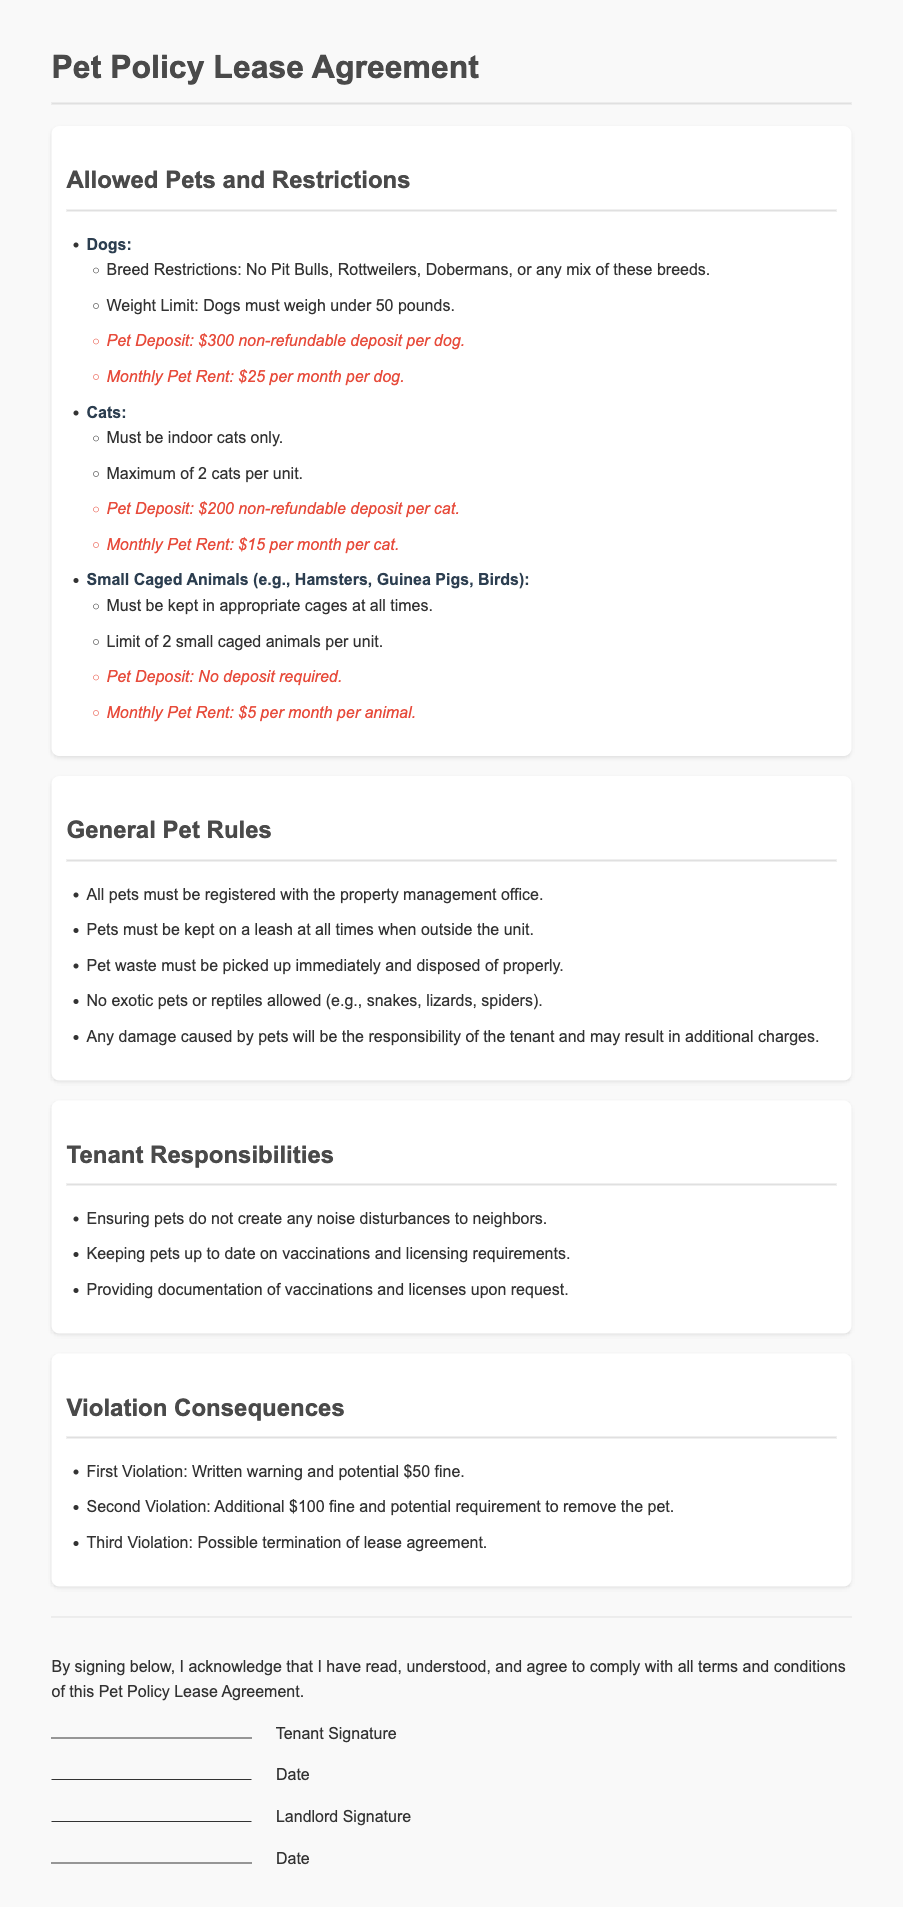What are the breed restrictions for dogs? The breed restrictions for dogs include No Pit Bulls, Rottweilers, Dobermans, or any mix of these breeds.
Answer: No Pit Bulls, Rottweilers, Dobermans What is the pet deposit for cats? The pet deposit for cats is mentioned in the document, which is $200 non-refundable deposit per cat.
Answer: $200 How many small caged animals are allowed per unit? The document specifies the limit for small caged animals, which is a maximum of 2 small caged animals per unit.
Answer: 2 What is the monthly pet rent for dogs? The document states that the monthly pet rent for dogs is $25 per month per dog.
Answer: $25 What consequence follows a second violation? The consequence for a second violation includes an additional fine and the potential requirement to remove the pet.
Answer: Additional $100 fine and potential removal How must pets be managed while outside the unit? The document outlines that pets must be kept on a leash at all times when outside the unit.
Answer: On a leash What documentation must tenants provide upon request? The tenants are required to provide documentation of vaccinations and licenses upon request.
Answer: Vaccinations and licenses What type of pets are explicitly not allowed? The document indicates that exotic pets or reptiles are not allowed, such as snakes, lizards, and spiders.
Answer: Exotic pets or reptiles 